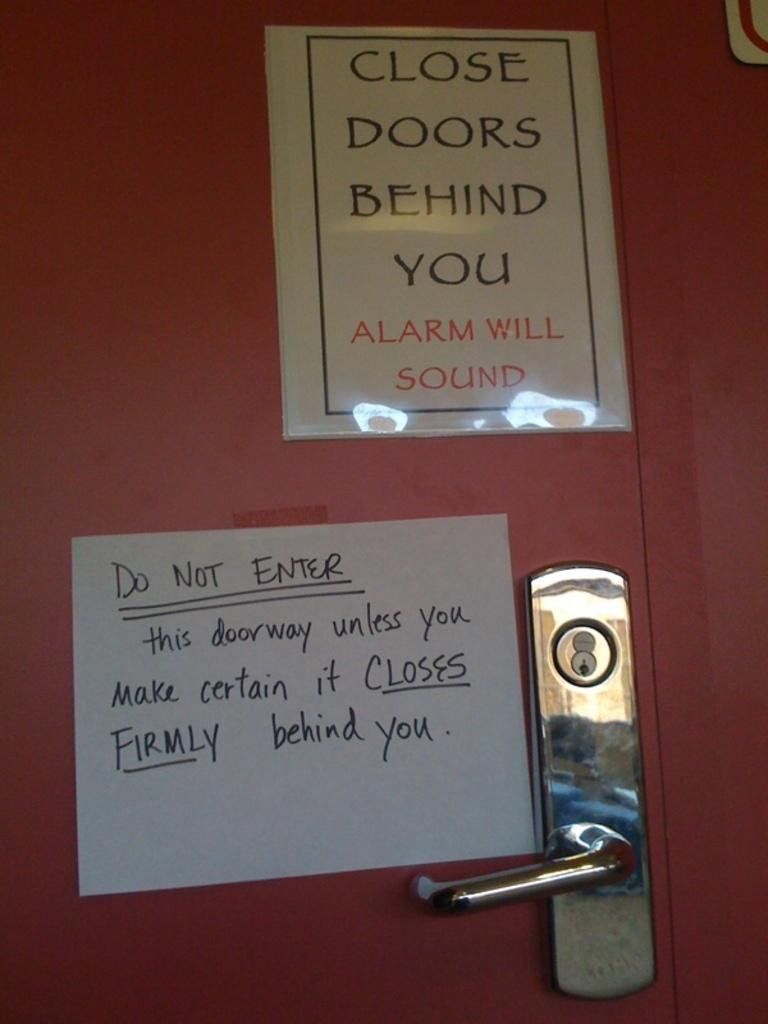<image>
Render a clear and concise summary of the photo. A close doors behind you sign is above a do not enter sign. 